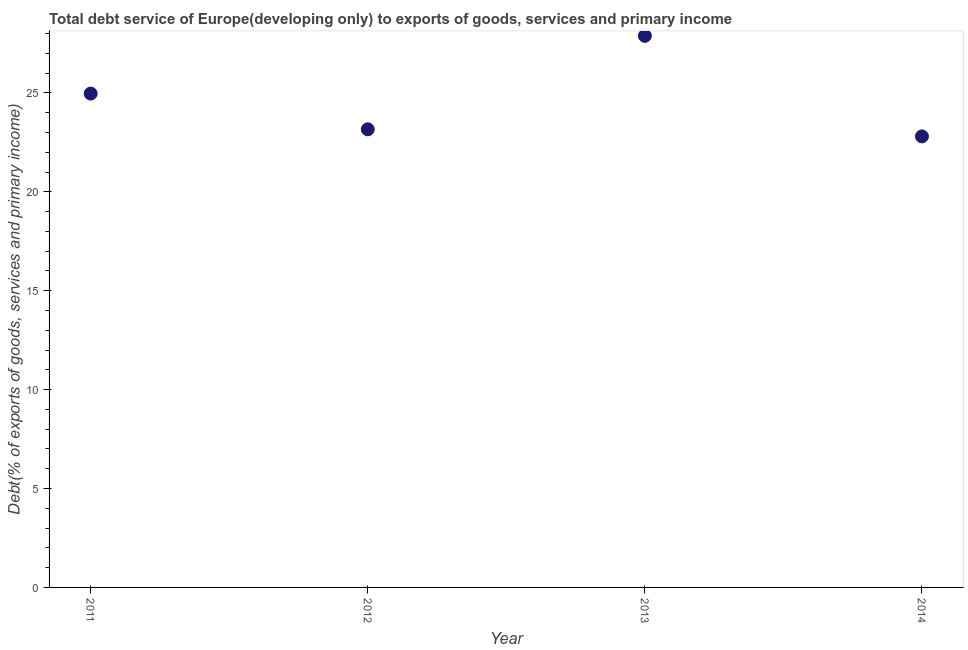What is the total debt service in 2013?
Give a very brief answer. 27.89. Across all years, what is the maximum total debt service?
Give a very brief answer. 27.89. Across all years, what is the minimum total debt service?
Provide a succinct answer. 22.8. In which year was the total debt service minimum?
Ensure brevity in your answer.  2014. What is the sum of the total debt service?
Ensure brevity in your answer.  98.82. What is the difference between the total debt service in 2013 and 2014?
Your answer should be compact. 5.08. What is the average total debt service per year?
Give a very brief answer. 24.71. What is the median total debt service?
Offer a terse response. 24.07. Do a majority of the years between 2012 and 2014 (inclusive) have total debt service greater than 8 %?
Keep it short and to the point. Yes. What is the ratio of the total debt service in 2011 to that in 2012?
Ensure brevity in your answer.  1.08. Is the difference between the total debt service in 2011 and 2014 greater than the difference between any two years?
Offer a very short reply. No. What is the difference between the highest and the second highest total debt service?
Give a very brief answer. 2.92. What is the difference between the highest and the lowest total debt service?
Provide a short and direct response. 5.08. In how many years, is the total debt service greater than the average total debt service taken over all years?
Offer a terse response. 2. How many years are there in the graph?
Offer a very short reply. 4. What is the difference between two consecutive major ticks on the Y-axis?
Give a very brief answer. 5. Are the values on the major ticks of Y-axis written in scientific E-notation?
Ensure brevity in your answer.  No. Does the graph contain any zero values?
Offer a terse response. No. Does the graph contain grids?
Your answer should be compact. No. What is the title of the graph?
Your response must be concise. Total debt service of Europe(developing only) to exports of goods, services and primary income. What is the label or title of the Y-axis?
Provide a succinct answer. Debt(% of exports of goods, services and primary income). What is the Debt(% of exports of goods, services and primary income) in 2011?
Offer a terse response. 24.97. What is the Debt(% of exports of goods, services and primary income) in 2012?
Make the answer very short. 23.16. What is the Debt(% of exports of goods, services and primary income) in 2013?
Give a very brief answer. 27.89. What is the Debt(% of exports of goods, services and primary income) in 2014?
Provide a short and direct response. 22.8. What is the difference between the Debt(% of exports of goods, services and primary income) in 2011 and 2012?
Make the answer very short. 1.81. What is the difference between the Debt(% of exports of goods, services and primary income) in 2011 and 2013?
Your answer should be very brief. -2.92. What is the difference between the Debt(% of exports of goods, services and primary income) in 2011 and 2014?
Your answer should be compact. 2.16. What is the difference between the Debt(% of exports of goods, services and primary income) in 2012 and 2013?
Your answer should be very brief. -4.73. What is the difference between the Debt(% of exports of goods, services and primary income) in 2012 and 2014?
Your response must be concise. 0.36. What is the difference between the Debt(% of exports of goods, services and primary income) in 2013 and 2014?
Offer a very short reply. 5.08. What is the ratio of the Debt(% of exports of goods, services and primary income) in 2011 to that in 2012?
Make the answer very short. 1.08. What is the ratio of the Debt(% of exports of goods, services and primary income) in 2011 to that in 2013?
Give a very brief answer. 0.9. What is the ratio of the Debt(% of exports of goods, services and primary income) in 2011 to that in 2014?
Your answer should be very brief. 1.09. What is the ratio of the Debt(% of exports of goods, services and primary income) in 2012 to that in 2013?
Give a very brief answer. 0.83. What is the ratio of the Debt(% of exports of goods, services and primary income) in 2013 to that in 2014?
Provide a succinct answer. 1.22. 